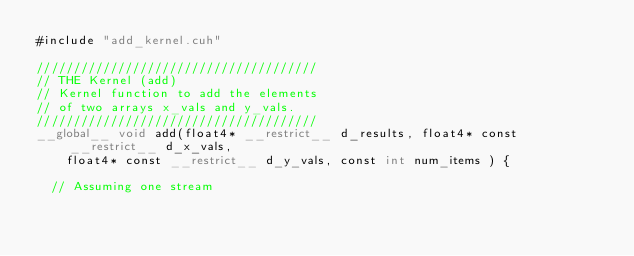<code> <loc_0><loc_0><loc_500><loc_500><_Cuda_>#include "add_kernel.cuh"

//////////////////////////////////////
// THE Kernel (add)
// Kernel function to add the elements 
// of two arrays x_vals and y_vals. 
//////////////////////////////////////
__global__ void add(float4* __restrict__ d_results, float4* const __restrict__ d_x_vals, 
    float4* const __restrict__ d_y_vals, const int num_items ) {

  // Assuming one stream</code> 